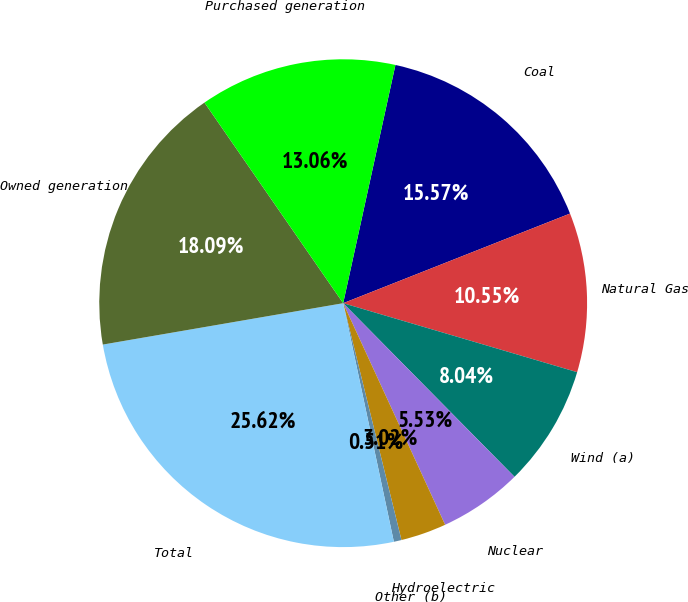Convert chart to OTSL. <chart><loc_0><loc_0><loc_500><loc_500><pie_chart><fcel>Coal<fcel>Natural Gas<fcel>Wind (a)<fcel>Nuclear<fcel>Hydroelectric<fcel>Other (b)<fcel>Total<fcel>Owned generation<fcel>Purchased generation<nl><fcel>15.57%<fcel>10.55%<fcel>8.04%<fcel>5.53%<fcel>3.02%<fcel>0.51%<fcel>25.61%<fcel>18.08%<fcel>13.06%<nl></chart> 